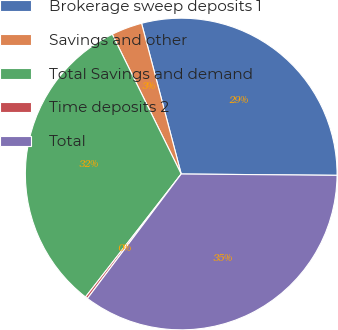Convert chart to OTSL. <chart><loc_0><loc_0><loc_500><loc_500><pie_chart><fcel>Brokerage sweep deposits 1<fcel>Savings and other<fcel>Total Savings and demand<fcel>Time deposits 2<fcel>Total<nl><fcel>29.23%<fcel>3.2%<fcel>32.18%<fcel>0.25%<fcel>35.14%<nl></chart> 